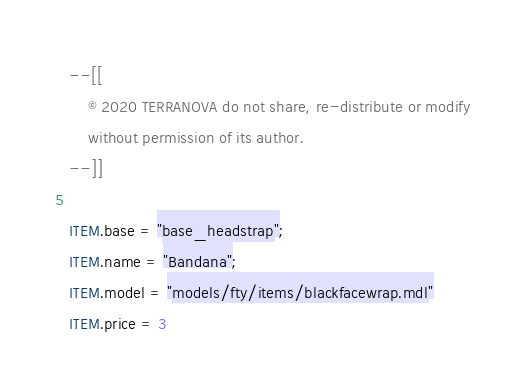<code> <loc_0><loc_0><loc_500><loc_500><_Lua_>--[[
	© 2020 TERRANOVA do not share, re-distribute or modify
	without permission of its author.
--]]

ITEM.base = "base_headstrap";
ITEM.name = "Bandana";
ITEM.model = "models/fty/items/blackfacewrap.mdl"
ITEM.price = 3</code> 